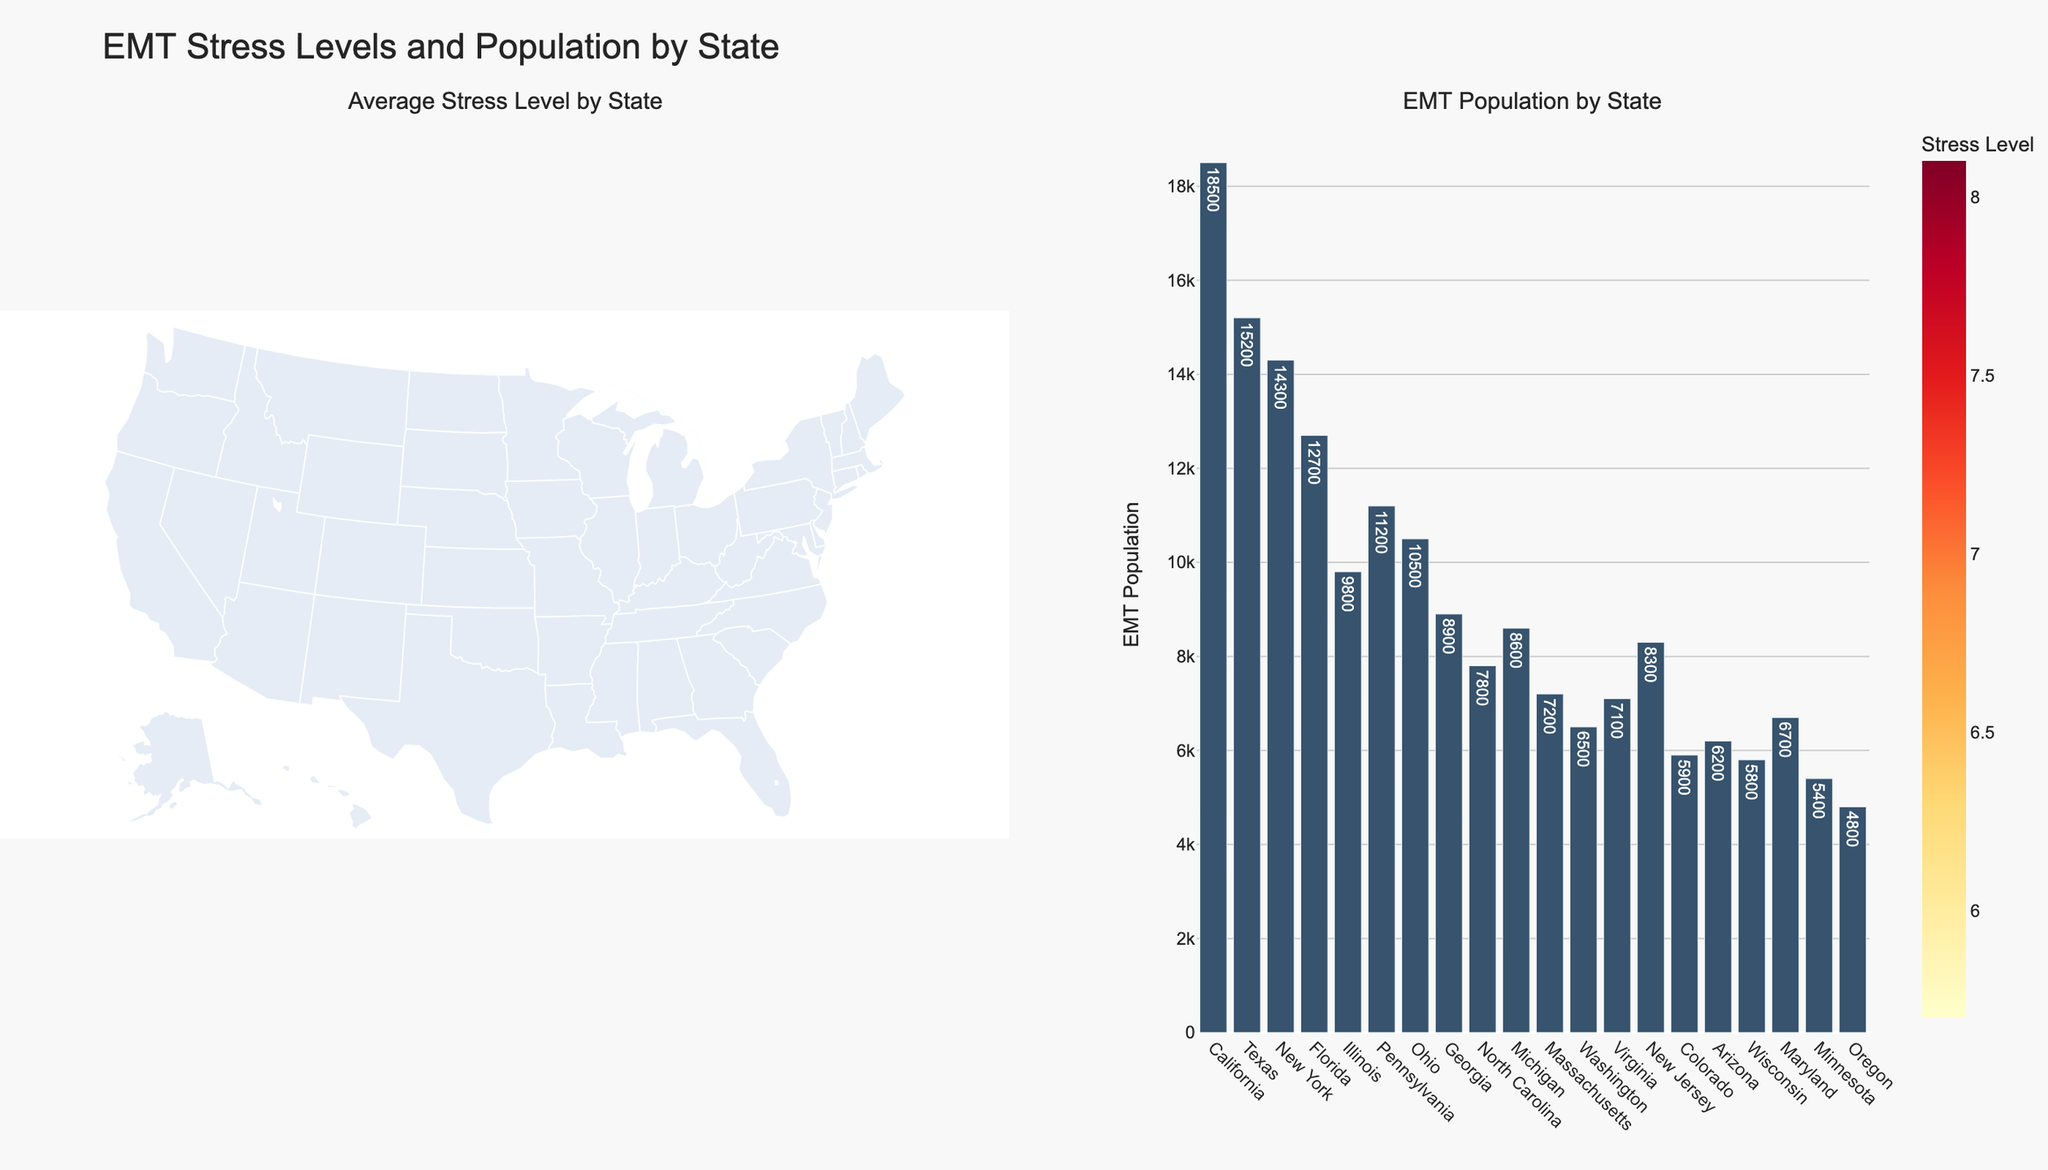What state has the highest average stress level for EMTs? The choropleth map shows color-coded stress levels, with the darkest color representing the highest stress. New York stands out with the darkest shade.
Answer: New York What is the average stress level for EMTs in Colorado? Colorado's stress level is listed in the bar chart and choropleth hover text. It is 5.9.
Answer: 5.9 How does the EMT population in Texas compare to that in New York? The bar chart shows the EMT population for each state. Texas has 15,200 EMTs and New York has 14,300 EMTs. Texas has a higher EMT population.
Answer: Texas has more EMTs What's the total number of EMTs represented in the figure? Add up the EMT population for all the states listed in the bar chart. The sum is 18500 + 15200 + 14300 + 12700 + 9800 + 11200 + 10500 + 8900 + 7800 + 8600 + 7200 + 6500 + 7100 + 8300 + 5900 + 6200 + 5800 + 6700 + 5400 + 4800.
Answer: 176,000 Among the states with over 10,000 EMTs, which has the lowest average stress level? First, identify the states with over 10,000 EMTs from the bar chart (California, Texas, New York, Florida, Pennsylvania, Ohio). Then, compare their stress levels. Florida (6.5) has the lowest.
Answer: Florida Which state has the lowest average stress level for EMTs? From the choropleth map, the lightest color indicates the lowest stress level. Oregon, with a stress level of 5.7, has the lightest shade.
Answer: Oregon What is the combined stress level average for California and Illinois? The average stress levels are 7.2 for California and 7.5 for Illinois. Find the sum and divide by 2. (7.2 + 7.5) / 2 = 7.35.
Answer: 7.35 How many states have an average stress level of 7 or higher? Identify states from the choropleth map or bar chart where the average stress level is 7 or above. California, New York, Illinois, Pennsylvania, Michigan, Massachusetts, New Jersey, Maryland. There are 8 states.
Answer: 8 Which state in the figure has the smallest EMT population? From the bar chart, the shortest bar indicates the smallest population. Oregon, with an EMT population of 4,800, has the smallest.
Answer: Oregon What's the average EMT population of the states with a stress level below 6? Identify and sum the EMT populations for states with stress levels below 6 (Colorado, Arizona, Wisconsin, Minnesota, Oregon). Then divide by the number of these states. (5900 + 6200 + 5800 + 5400 + 4800) / 5 = 5,800.
Answer: 5,800 